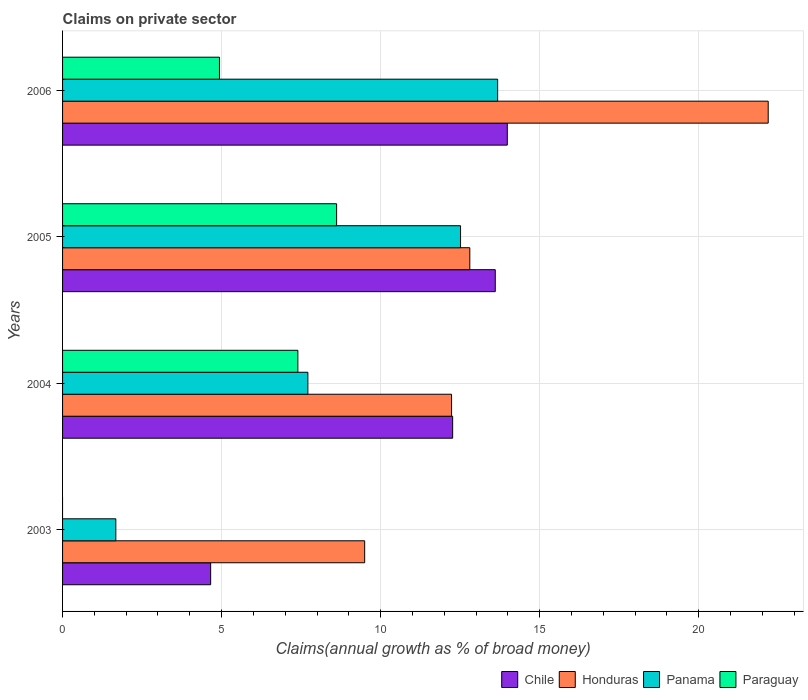How many groups of bars are there?
Offer a very short reply. 4. Are the number of bars per tick equal to the number of legend labels?
Offer a very short reply. No. Are the number of bars on each tick of the Y-axis equal?
Offer a terse response. No. How many bars are there on the 3rd tick from the top?
Ensure brevity in your answer.  4. How many bars are there on the 1st tick from the bottom?
Keep it short and to the point. 3. What is the label of the 4th group of bars from the top?
Keep it short and to the point. 2003. In how many cases, is the number of bars for a given year not equal to the number of legend labels?
Keep it short and to the point. 1. What is the percentage of broad money claimed on private sector in Panama in 2004?
Keep it short and to the point. 7.71. Across all years, what is the maximum percentage of broad money claimed on private sector in Honduras?
Provide a succinct answer. 22.19. Across all years, what is the minimum percentage of broad money claimed on private sector in Panama?
Give a very brief answer. 1.67. What is the total percentage of broad money claimed on private sector in Paraguay in the graph?
Ensure brevity in your answer.  20.95. What is the difference between the percentage of broad money claimed on private sector in Panama in 2003 and that in 2004?
Make the answer very short. -6.04. What is the difference between the percentage of broad money claimed on private sector in Honduras in 2005 and the percentage of broad money claimed on private sector in Paraguay in 2003?
Provide a succinct answer. 12.8. What is the average percentage of broad money claimed on private sector in Chile per year?
Your answer should be very brief. 11.13. In the year 2004, what is the difference between the percentage of broad money claimed on private sector in Honduras and percentage of broad money claimed on private sector in Panama?
Ensure brevity in your answer.  4.52. In how many years, is the percentage of broad money claimed on private sector in Chile greater than 9 %?
Ensure brevity in your answer.  3. What is the ratio of the percentage of broad money claimed on private sector in Honduras in 2004 to that in 2005?
Make the answer very short. 0.96. Is the percentage of broad money claimed on private sector in Honduras in 2005 less than that in 2006?
Your response must be concise. Yes. Is the difference between the percentage of broad money claimed on private sector in Honduras in 2003 and 2005 greater than the difference between the percentage of broad money claimed on private sector in Panama in 2003 and 2005?
Make the answer very short. Yes. What is the difference between the highest and the second highest percentage of broad money claimed on private sector in Panama?
Provide a succinct answer. 1.17. What is the difference between the highest and the lowest percentage of broad money claimed on private sector in Chile?
Give a very brief answer. 9.33. Is the sum of the percentage of broad money claimed on private sector in Panama in 2003 and 2006 greater than the maximum percentage of broad money claimed on private sector in Chile across all years?
Your answer should be very brief. Yes. Is it the case that in every year, the sum of the percentage of broad money claimed on private sector in Chile and percentage of broad money claimed on private sector in Panama is greater than the percentage of broad money claimed on private sector in Honduras?
Your answer should be very brief. No. How many bars are there?
Give a very brief answer. 15. Are all the bars in the graph horizontal?
Your answer should be compact. Yes. How many years are there in the graph?
Your answer should be very brief. 4. What is the difference between two consecutive major ticks on the X-axis?
Keep it short and to the point. 5. Does the graph contain any zero values?
Keep it short and to the point. Yes. Does the graph contain grids?
Your response must be concise. Yes. How many legend labels are there?
Offer a very short reply. 4. What is the title of the graph?
Ensure brevity in your answer.  Claims on private sector. Does "French Polynesia" appear as one of the legend labels in the graph?
Make the answer very short. No. What is the label or title of the X-axis?
Offer a very short reply. Claims(annual growth as % of broad money). What is the label or title of the Y-axis?
Ensure brevity in your answer.  Years. What is the Claims(annual growth as % of broad money) in Chile in 2003?
Make the answer very short. 4.66. What is the Claims(annual growth as % of broad money) of Honduras in 2003?
Offer a terse response. 9.5. What is the Claims(annual growth as % of broad money) in Panama in 2003?
Offer a terse response. 1.67. What is the Claims(annual growth as % of broad money) in Chile in 2004?
Offer a very short reply. 12.26. What is the Claims(annual growth as % of broad money) of Honduras in 2004?
Your answer should be very brief. 12.23. What is the Claims(annual growth as % of broad money) in Panama in 2004?
Ensure brevity in your answer.  7.71. What is the Claims(annual growth as % of broad money) in Paraguay in 2004?
Offer a terse response. 7.4. What is the Claims(annual growth as % of broad money) in Chile in 2005?
Offer a terse response. 13.6. What is the Claims(annual growth as % of broad money) in Honduras in 2005?
Keep it short and to the point. 12.8. What is the Claims(annual growth as % of broad money) in Panama in 2005?
Ensure brevity in your answer.  12.51. What is the Claims(annual growth as % of broad money) in Paraguay in 2005?
Offer a very short reply. 8.62. What is the Claims(annual growth as % of broad money) of Chile in 2006?
Ensure brevity in your answer.  13.98. What is the Claims(annual growth as % of broad money) in Honduras in 2006?
Give a very brief answer. 22.19. What is the Claims(annual growth as % of broad money) in Panama in 2006?
Give a very brief answer. 13.68. What is the Claims(annual growth as % of broad money) of Paraguay in 2006?
Your answer should be compact. 4.93. Across all years, what is the maximum Claims(annual growth as % of broad money) in Chile?
Make the answer very short. 13.98. Across all years, what is the maximum Claims(annual growth as % of broad money) in Honduras?
Offer a very short reply. 22.19. Across all years, what is the maximum Claims(annual growth as % of broad money) in Panama?
Give a very brief answer. 13.68. Across all years, what is the maximum Claims(annual growth as % of broad money) of Paraguay?
Make the answer very short. 8.62. Across all years, what is the minimum Claims(annual growth as % of broad money) in Chile?
Keep it short and to the point. 4.66. Across all years, what is the minimum Claims(annual growth as % of broad money) in Honduras?
Give a very brief answer. 9.5. Across all years, what is the minimum Claims(annual growth as % of broad money) of Panama?
Your answer should be very brief. 1.67. What is the total Claims(annual growth as % of broad money) of Chile in the graph?
Keep it short and to the point. 44.51. What is the total Claims(annual growth as % of broad money) in Honduras in the graph?
Your answer should be compact. 56.72. What is the total Claims(annual growth as % of broad money) in Panama in the graph?
Your response must be concise. 35.58. What is the total Claims(annual growth as % of broad money) in Paraguay in the graph?
Your answer should be compact. 20.95. What is the difference between the Claims(annual growth as % of broad money) in Chile in 2003 and that in 2004?
Your response must be concise. -7.61. What is the difference between the Claims(annual growth as % of broad money) of Honduras in 2003 and that in 2004?
Provide a succinct answer. -2.73. What is the difference between the Claims(annual growth as % of broad money) of Panama in 2003 and that in 2004?
Keep it short and to the point. -6.04. What is the difference between the Claims(annual growth as % of broad money) in Chile in 2003 and that in 2005?
Your answer should be very brief. -8.95. What is the difference between the Claims(annual growth as % of broad money) in Honduras in 2003 and that in 2005?
Your answer should be very brief. -3.31. What is the difference between the Claims(annual growth as % of broad money) in Panama in 2003 and that in 2005?
Provide a short and direct response. -10.84. What is the difference between the Claims(annual growth as % of broad money) in Chile in 2003 and that in 2006?
Keep it short and to the point. -9.33. What is the difference between the Claims(annual growth as % of broad money) of Honduras in 2003 and that in 2006?
Provide a succinct answer. -12.69. What is the difference between the Claims(annual growth as % of broad money) in Panama in 2003 and that in 2006?
Provide a succinct answer. -12. What is the difference between the Claims(annual growth as % of broad money) of Chile in 2004 and that in 2005?
Ensure brevity in your answer.  -1.34. What is the difference between the Claims(annual growth as % of broad money) in Honduras in 2004 and that in 2005?
Provide a succinct answer. -0.57. What is the difference between the Claims(annual growth as % of broad money) in Panama in 2004 and that in 2005?
Make the answer very short. -4.8. What is the difference between the Claims(annual growth as % of broad money) in Paraguay in 2004 and that in 2005?
Your answer should be compact. -1.22. What is the difference between the Claims(annual growth as % of broad money) in Chile in 2004 and that in 2006?
Make the answer very short. -1.72. What is the difference between the Claims(annual growth as % of broad money) in Honduras in 2004 and that in 2006?
Your response must be concise. -9.96. What is the difference between the Claims(annual growth as % of broad money) in Panama in 2004 and that in 2006?
Keep it short and to the point. -5.97. What is the difference between the Claims(annual growth as % of broad money) in Paraguay in 2004 and that in 2006?
Ensure brevity in your answer.  2.46. What is the difference between the Claims(annual growth as % of broad money) of Chile in 2005 and that in 2006?
Your answer should be compact. -0.38. What is the difference between the Claims(annual growth as % of broad money) in Honduras in 2005 and that in 2006?
Your answer should be compact. -9.38. What is the difference between the Claims(annual growth as % of broad money) in Panama in 2005 and that in 2006?
Offer a terse response. -1.17. What is the difference between the Claims(annual growth as % of broad money) in Paraguay in 2005 and that in 2006?
Your answer should be compact. 3.68. What is the difference between the Claims(annual growth as % of broad money) in Chile in 2003 and the Claims(annual growth as % of broad money) in Honduras in 2004?
Provide a succinct answer. -7.57. What is the difference between the Claims(annual growth as % of broad money) in Chile in 2003 and the Claims(annual growth as % of broad money) in Panama in 2004?
Your response must be concise. -3.06. What is the difference between the Claims(annual growth as % of broad money) in Chile in 2003 and the Claims(annual growth as % of broad money) in Paraguay in 2004?
Ensure brevity in your answer.  -2.74. What is the difference between the Claims(annual growth as % of broad money) of Honduras in 2003 and the Claims(annual growth as % of broad money) of Panama in 2004?
Your answer should be very brief. 1.79. What is the difference between the Claims(annual growth as % of broad money) in Honduras in 2003 and the Claims(annual growth as % of broad money) in Paraguay in 2004?
Offer a very short reply. 2.1. What is the difference between the Claims(annual growth as % of broad money) in Panama in 2003 and the Claims(annual growth as % of broad money) in Paraguay in 2004?
Give a very brief answer. -5.72. What is the difference between the Claims(annual growth as % of broad money) in Chile in 2003 and the Claims(annual growth as % of broad money) in Honduras in 2005?
Provide a succinct answer. -8.15. What is the difference between the Claims(annual growth as % of broad money) of Chile in 2003 and the Claims(annual growth as % of broad money) of Panama in 2005?
Offer a very short reply. -7.86. What is the difference between the Claims(annual growth as % of broad money) in Chile in 2003 and the Claims(annual growth as % of broad money) in Paraguay in 2005?
Your answer should be very brief. -3.96. What is the difference between the Claims(annual growth as % of broad money) of Honduras in 2003 and the Claims(annual growth as % of broad money) of Panama in 2005?
Offer a terse response. -3.01. What is the difference between the Claims(annual growth as % of broad money) of Honduras in 2003 and the Claims(annual growth as % of broad money) of Paraguay in 2005?
Offer a very short reply. 0.88. What is the difference between the Claims(annual growth as % of broad money) in Panama in 2003 and the Claims(annual growth as % of broad money) in Paraguay in 2005?
Offer a terse response. -6.94. What is the difference between the Claims(annual growth as % of broad money) in Chile in 2003 and the Claims(annual growth as % of broad money) in Honduras in 2006?
Your answer should be very brief. -17.53. What is the difference between the Claims(annual growth as % of broad money) of Chile in 2003 and the Claims(annual growth as % of broad money) of Panama in 2006?
Offer a terse response. -9.02. What is the difference between the Claims(annual growth as % of broad money) in Chile in 2003 and the Claims(annual growth as % of broad money) in Paraguay in 2006?
Provide a short and direct response. -0.28. What is the difference between the Claims(annual growth as % of broad money) of Honduras in 2003 and the Claims(annual growth as % of broad money) of Panama in 2006?
Give a very brief answer. -4.18. What is the difference between the Claims(annual growth as % of broad money) in Honduras in 2003 and the Claims(annual growth as % of broad money) in Paraguay in 2006?
Your answer should be very brief. 4.56. What is the difference between the Claims(annual growth as % of broad money) of Panama in 2003 and the Claims(annual growth as % of broad money) of Paraguay in 2006?
Offer a terse response. -3.26. What is the difference between the Claims(annual growth as % of broad money) of Chile in 2004 and the Claims(annual growth as % of broad money) of Honduras in 2005?
Your response must be concise. -0.54. What is the difference between the Claims(annual growth as % of broad money) of Chile in 2004 and the Claims(annual growth as % of broad money) of Panama in 2005?
Ensure brevity in your answer.  -0.25. What is the difference between the Claims(annual growth as % of broad money) in Chile in 2004 and the Claims(annual growth as % of broad money) in Paraguay in 2005?
Make the answer very short. 3.65. What is the difference between the Claims(annual growth as % of broad money) in Honduras in 2004 and the Claims(annual growth as % of broad money) in Panama in 2005?
Your response must be concise. -0.28. What is the difference between the Claims(annual growth as % of broad money) of Honduras in 2004 and the Claims(annual growth as % of broad money) of Paraguay in 2005?
Keep it short and to the point. 3.61. What is the difference between the Claims(annual growth as % of broad money) of Panama in 2004 and the Claims(annual growth as % of broad money) of Paraguay in 2005?
Provide a succinct answer. -0.9. What is the difference between the Claims(annual growth as % of broad money) in Chile in 2004 and the Claims(annual growth as % of broad money) in Honduras in 2006?
Offer a very short reply. -9.92. What is the difference between the Claims(annual growth as % of broad money) of Chile in 2004 and the Claims(annual growth as % of broad money) of Panama in 2006?
Offer a terse response. -1.41. What is the difference between the Claims(annual growth as % of broad money) in Chile in 2004 and the Claims(annual growth as % of broad money) in Paraguay in 2006?
Keep it short and to the point. 7.33. What is the difference between the Claims(annual growth as % of broad money) in Honduras in 2004 and the Claims(annual growth as % of broad money) in Panama in 2006?
Your response must be concise. -1.45. What is the difference between the Claims(annual growth as % of broad money) of Honduras in 2004 and the Claims(annual growth as % of broad money) of Paraguay in 2006?
Your answer should be very brief. 7.3. What is the difference between the Claims(annual growth as % of broad money) in Panama in 2004 and the Claims(annual growth as % of broad money) in Paraguay in 2006?
Give a very brief answer. 2.78. What is the difference between the Claims(annual growth as % of broad money) of Chile in 2005 and the Claims(annual growth as % of broad money) of Honduras in 2006?
Offer a very short reply. -8.58. What is the difference between the Claims(annual growth as % of broad money) in Chile in 2005 and the Claims(annual growth as % of broad money) in Panama in 2006?
Provide a succinct answer. -0.07. What is the difference between the Claims(annual growth as % of broad money) in Chile in 2005 and the Claims(annual growth as % of broad money) in Paraguay in 2006?
Give a very brief answer. 8.67. What is the difference between the Claims(annual growth as % of broad money) of Honduras in 2005 and the Claims(annual growth as % of broad money) of Panama in 2006?
Your answer should be very brief. -0.88. What is the difference between the Claims(annual growth as % of broad money) in Honduras in 2005 and the Claims(annual growth as % of broad money) in Paraguay in 2006?
Offer a terse response. 7.87. What is the difference between the Claims(annual growth as % of broad money) in Panama in 2005 and the Claims(annual growth as % of broad money) in Paraguay in 2006?
Provide a succinct answer. 7.58. What is the average Claims(annual growth as % of broad money) in Chile per year?
Your response must be concise. 11.13. What is the average Claims(annual growth as % of broad money) of Honduras per year?
Give a very brief answer. 14.18. What is the average Claims(annual growth as % of broad money) in Panama per year?
Give a very brief answer. 8.89. What is the average Claims(annual growth as % of broad money) in Paraguay per year?
Your answer should be very brief. 5.24. In the year 2003, what is the difference between the Claims(annual growth as % of broad money) in Chile and Claims(annual growth as % of broad money) in Honduras?
Ensure brevity in your answer.  -4.84. In the year 2003, what is the difference between the Claims(annual growth as % of broad money) in Chile and Claims(annual growth as % of broad money) in Panama?
Keep it short and to the point. 2.98. In the year 2003, what is the difference between the Claims(annual growth as % of broad money) of Honduras and Claims(annual growth as % of broad money) of Panama?
Offer a very short reply. 7.82. In the year 2004, what is the difference between the Claims(annual growth as % of broad money) of Chile and Claims(annual growth as % of broad money) of Honduras?
Provide a succinct answer. 0.03. In the year 2004, what is the difference between the Claims(annual growth as % of broad money) in Chile and Claims(annual growth as % of broad money) in Panama?
Your answer should be very brief. 4.55. In the year 2004, what is the difference between the Claims(annual growth as % of broad money) in Chile and Claims(annual growth as % of broad money) in Paraguay?
Make the answer very short. 4.87. In the year 2004, what is the difference between the Claims(annual growth as % of broad money) in Honduras and Claims(annual growth as % of broad money) in Panama?
Provide a short and direct response. 4.52. In the year 2004, what is the difference between the Claims(annual growth as % of broad money) of Honduras and Claims(annual growth as % of broad money) of Paraguay?
Provide a succinct answer. 4.83. In the year 2004, what is the difference between the Claims(annual growth as % of broad money) in Panama and Claims(annual growth as % of broad money) in Paraguay?
Provide a succinct answer. 0.32. In the year 2005, what is the difference between the Claims(annual growth as % of broad money) of Chile and Claims(annual growth as % of broad money) of Honduras?
Your answer should be compact. 0.8. In the year 2005, what is the difference between the Claims(annual growth as % of broad money) in Chile and Claims(annual growth as % of broad money) in Panama?
Provide a short and direct response. 1.09. In the year 2005, what is the difference between the Claims(annual growth as % of broad money) of Chile and Claims(annual growth as % of broad money) of Paraguay?
Make the answer very short. 4.99. In the year 2005, what is the difference between the Claims(annual growth as % of broad money) in Honduras and Claims(annual growth as % of broad money) in Panama?
Give a very brief answer. 0.29. In the year 2005, what is the difference between the Claims(annual growth as % of broad money) of Honduras and Claims(annual growth as % of broad money) of Paraguay?
Offer a terse response. 4.19. In the year 2005, what is the difference between the Claims(annual growth as % of broad money) in Panama and Claims(annual growth as % of broad money) in Paraguay?
Offer a terse response. 3.9. In the year 2006, what is the difference between the Claims(annual growth as % of broad money) in Chile and Claims(annual growth as % of broad money) in Honduras?
Provide a short and direct response. -8.2. In the year 2006, what is the difference between the Claims(annual growth as % of broad money) in Chile and Claims(annual growth as % of broad money) in Panama?
Give a very brief answer. 0.3. In the year 2006, what is the difference between the Claims(annual growth as % of broad money) in Chile and Claims(annual growth as % of broad money) in Paraguay?
Give a very brief answer. 9.05. In the year 2006, what is the difference between the Claims(annual growth as % of broad money) of Honduras and Claims(annual growth as % of broad money) of Panama?
Provide a short and direct response. 8.51. In the year 2006, what is the difference between the Claims(annual growth as % of broad money) of Honduras and Claims(annual growth as % of broad money) of Paraguay?
Provide a short and direct response. 17.25. In the year 2006, what is the difference between the Claims(annual growth as % of broad money) in Panama and Claims(annual growth as % of broad money) in Paraguay?
Give a very brief answer. 8.75. What is the ratio of the Claims(annual growth as % of broad money) of Chile in 2003 to that in 2004?
Your answer should be compact. 0.38. What is the ratio of the Claims(annual growth as % of broad money) of Honduras in 2003 to that in 2004?
Ensure brevity in your answer.  0.78. What is the ratio of the Claims(annual growth as % of broad money) in Panama in 2003 to that in 2004?
Your answer should be compact. 0.22. What is the ratio of the Claims(annual growth as % of broad money) in Chile in 2003 to that in 2005?
Make the answer very short. 0.34. What is the ratio of the Claims(annual growth as % of broad money) in Honduras in 2003 to that in 2005?
Your answer should be very brief. 0.74. What is the ratio of the Claims(annual growth as % of broad money) in Panama in 2003 to that in 2005?
Provide a short and direct response. 0.13. What is the ratio of the Claims(annual growth as % of broad money) of Chile in 2003 to that in 2006?
Your response must be concise. 0.33. What is the ratio of the Claims(annual growth as % of broad money) of Honduras in 2003 to that in 2006?
Make the answer very short. 0.43. What is the ratio of the Claims(annual growth as % of broad money) in Panama in 2003 to that in 2006?
Offer a very short reply. 0.12. What is the ratio of the Claims(annual growth as % of broad money) of Chile in 2004 to that in 2005?
Your answer should be very brief. 0.9. What is the ratio of the Claims(annual growth as % of broad money) of Honduras in 2004 to that in 2005?
Your response must be concise. 0.96. What is the ratio of the Claims(annual growth as % of broad money) of Panama in 2004 to that in 2005?
Offer a terse response. 0.62. What is the ratio of the Claims(annual growth as % of broad money) in Paraguay in 2004 to that in 2005?
Make the answer very short. 0.86. What is the ratio of the Claims(annual growth as % of broad money) of Chile in 2004 to that in 2006?
Your answer should be compact. 0.88. What is the ratio of the Claims(annual growth as % of broad money) in Honduras in 2004 to that in 2006?
Provide a succinct answer. 0.55. What is the ratio of the Claims(annual growth as % of broad money) in Panama in 2004 to that in 2006?
Your response must be concise. 0.56. What is the ratio of the Claims(annual growth as % of broad money) in Paraguay in 2004 to that in 2006?
Your answer should be very brief. 1.5. What is the ratio of the Claims(annual growth as % of broad money) of Chile in 2005 to that in 2006?
Keep it short and to the point. 0.97. What is the ratio of the Claims(annual growth as % of broad money) in Honduras in 2005 to that in 2006?
Make the answer very short. 0.58. What is the ratio of the Claims(annual growth as % of broad money) of Panama in 2005 to that in 2006?
Provide a succinct answer. 0.91. What is the ratio of the Claims(annual growth as % of broad money) of Paraguay in 2005 to that in 2006?
Make the answer very short. 1.75. What is the difference between the highest and the second highest Claims(annual growth as % of broad money) of Chile?
Provide a succinct answer. 0.38. What is the difference between the highest and the second highest Claims(annual growth as % of broad money) in Honduras?
Offer a terse response. 9.38. What is the difference between the highest and the second highest Claims(annual growth as % of broad money) in Panama?
Offer a terse response. 1.17. What is the difference between the highest and the second highest Claims(annual growth as % of broad money) of Paraguay?
Provide a short and direct response. 1.22. What is the difference between the highest and the lowest Claims(annual growth as % of broad money) of Chile?
Make the answer very short. 9.33. What is the difference between the highest and the lowest Claims(annual growth as % of broad money) in Honduras?
Give a very brief answer. 12.69. What is the difference between the highest and the lowest Claims(annual growth as % of broad money) in Panama?
Give a very brief answer. 12. What is the difference between the highest and the lowest Claims(annual growth as % of broad money) of Paraguay?
Offer a terse response. 8.62. 